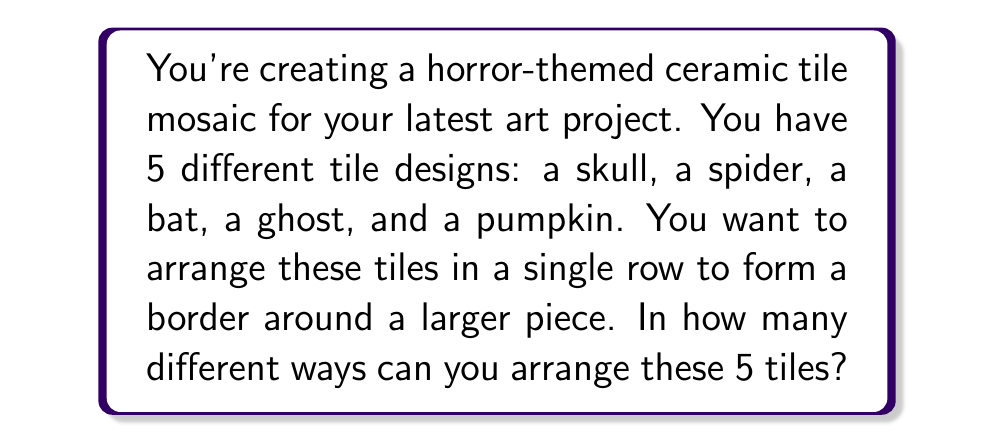Teach me how to tackle this problem. To solve this problem, we need to use the concept of permutations. A permutation is an arrangement of objects where order matters.

In this case:
1. We have 5 different tile designs.
2. We need to arrange all 5 tiles.
3. The order of the tiles matters (different orders create different designs).

The formula for permutations of n distinct objects is:

$$P(n) = n!$$

Where $n!$ (n factorial) is the product of all positive integers less than or equal to n.

In our case, $n = 5$, so we calculate:

$$P(5) = 5! = 5 \times 4 \times 3 \times 2 \times 1 = 120$$

Therefore, there are 120 different ways to arrange the 5 horror-themed tiles.

This means you have 120 unique options for your border design, allowing for a wide variety of aesthetic choices in your horror-themed ceramic art project.
Answer: $120$ unique arrangements 